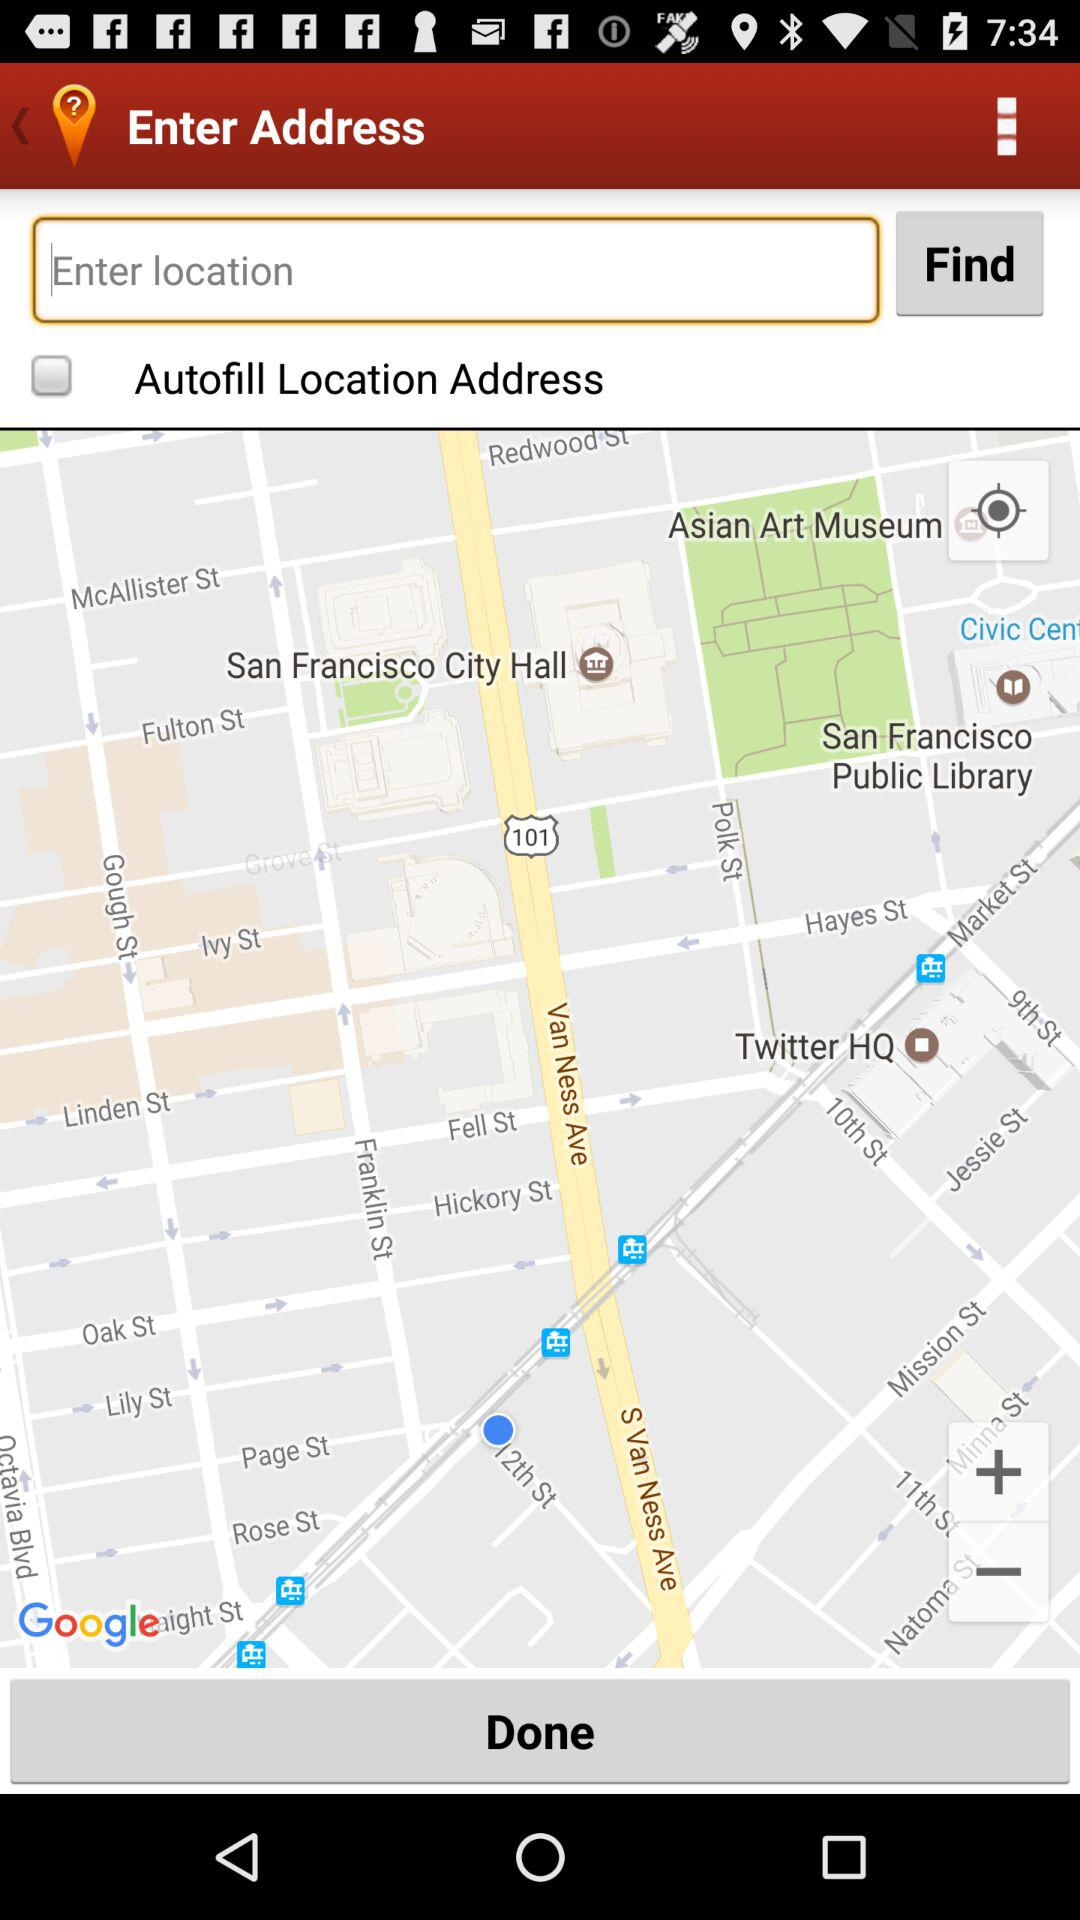What is the status of the "Autofill Location Address" setting? The status of the "Autofill Location Address" setting is "off". 